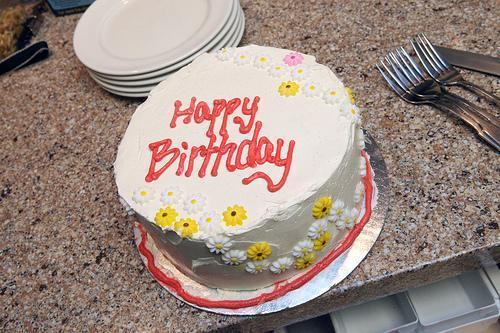How many cakes are in the photo?
Give a very brief answer. 1. 